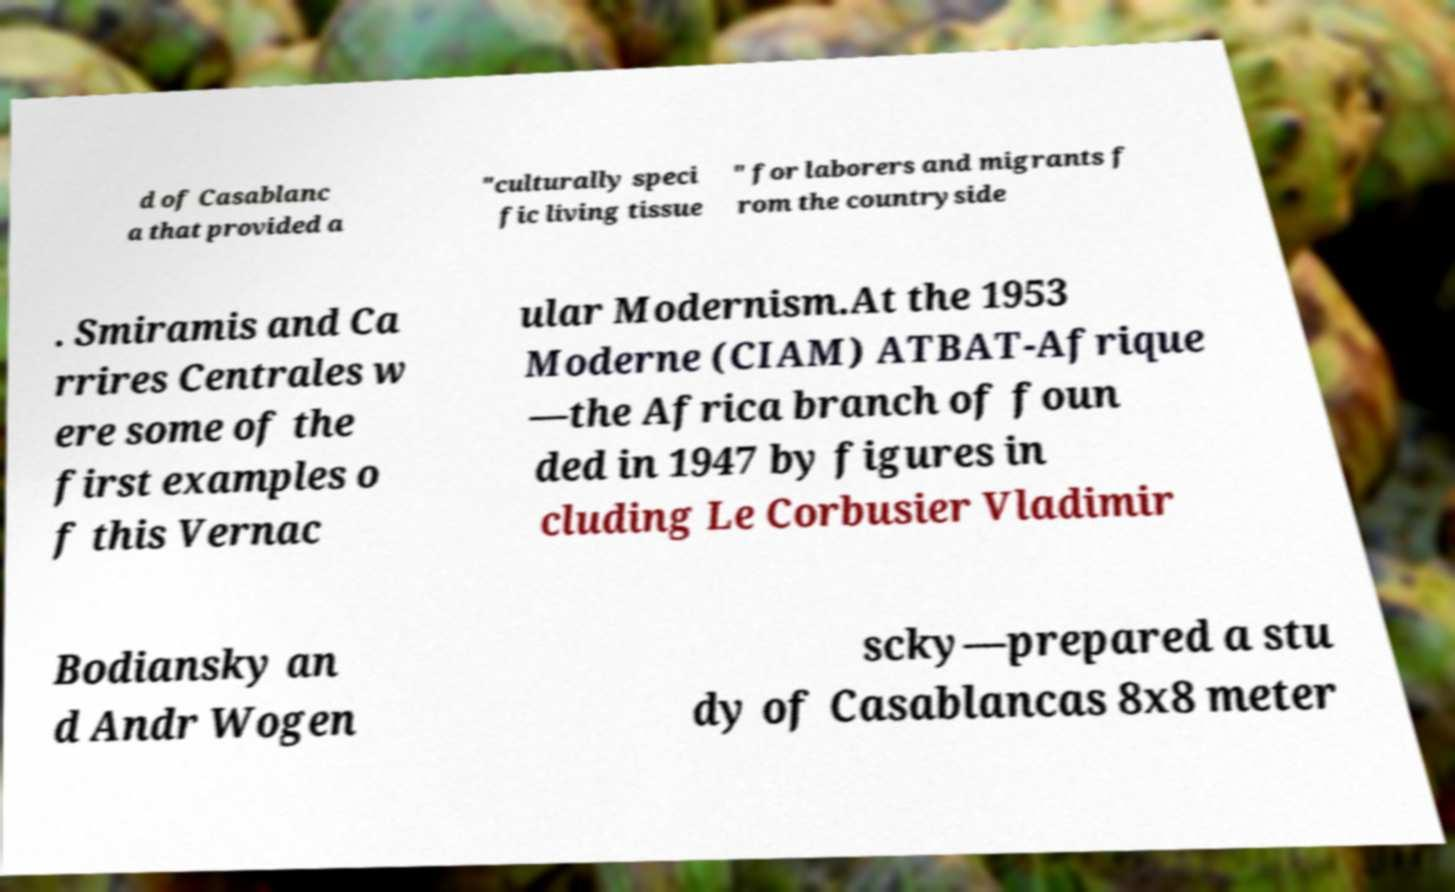Could you extract and type out the text from this image? d of Casablanc a that provided a "culturally speci fic living tissue " for laborers and migrants f rom the countryside . Smiramis and Ca rrires Centrales w ere some of the first examples o f this Vernac ular Modernism.At the 1953 Moderne (CIAM) ATBAT-Afrique —the Africa branch of foun ded in 1947 by figures in cluding Le Corbusier Vladimir Bodiansky an d Andr Wogen scky—prepared a stu dy of Casablancas 8x8 meter 